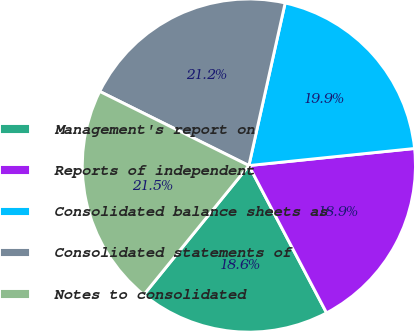Convert chart. <chart><loc_0><loc_0><loc_500><loc_500><pie_chart><fcel>Management's report on<fcel>Reports of independent<fcel>Consolidated balance sheets as<fcel>Consolidated statements of<fcel>Notes to consolidated<nl><fcel>18.59%<fcel>18.91%<fcel>19.87%<fcel>21.15%<fcel>21.47%<nl></chart> 